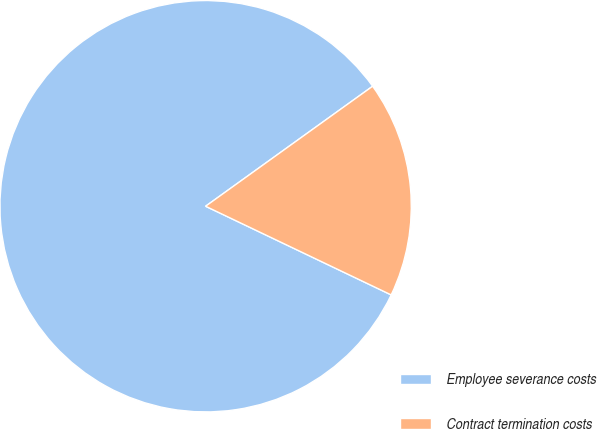Convert chart to OTSL. <chart><loc_0><loc_0><loc_500><loc_500><pie_chart><fcel>Employee severance costs<fcel>Contract termination costs<nl><fcel>82.99%<fcel>17.01%<nl></chart> 